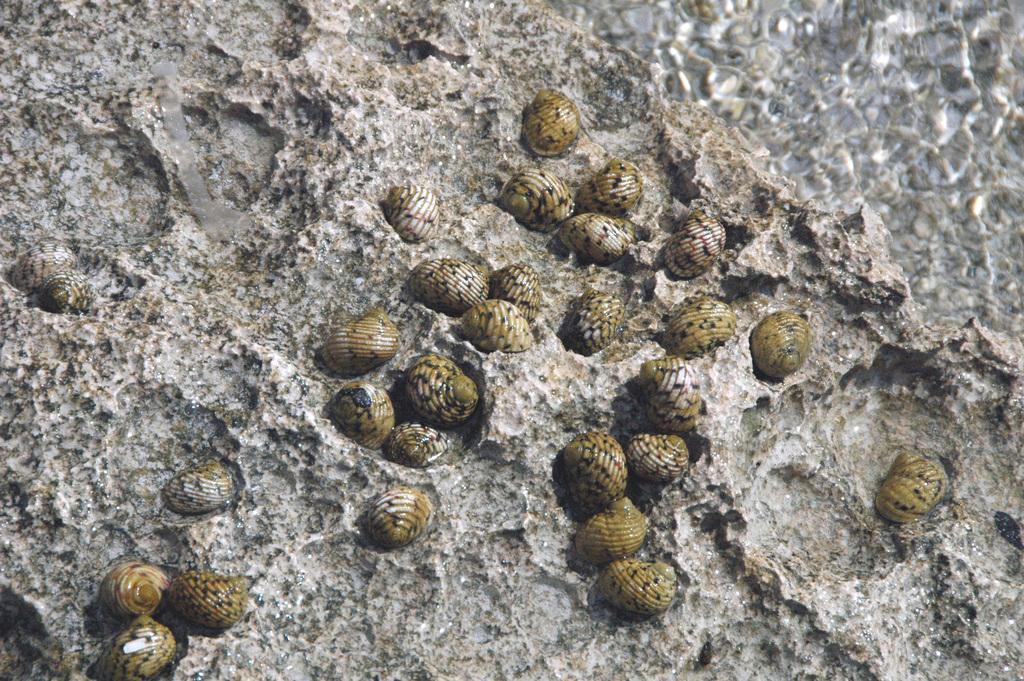Please provide a concise description of this image. In this image, we can see shells and at the bottom, there is sand. 